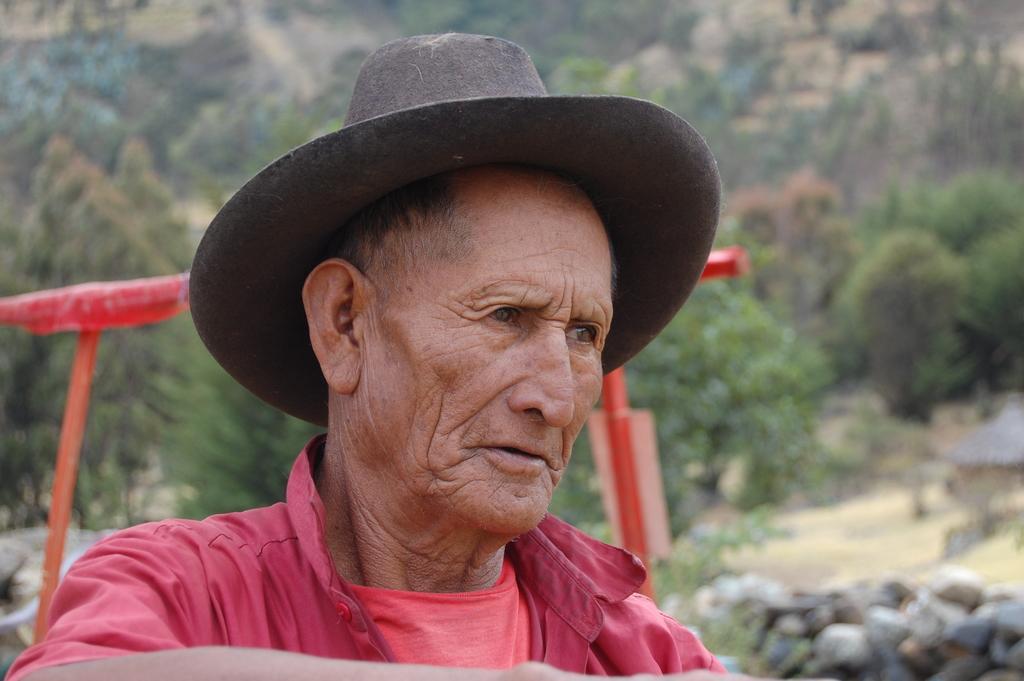Describe this image in one or two sentences. In this picture I can see a man is wearing a cap and I can see trees and few rocks and looks like a hut on the right side of the picture. 